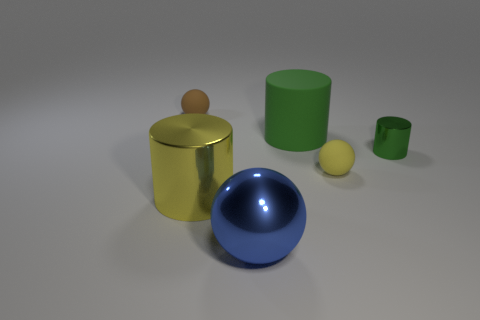Add 3 tiny brown spheres. How many objects exist? 9 Subtract all small rubber spheres. How many spheres are left? 1 Add 6 yellow metal cylinders. How many yellow metal cylinders are left? 7 Add 4 small blue matte objects. How many small blue matte objects exist? 4 Subtract all green cylinders. How many cylinders are left? 1 Subtract 0 yellow blocks. How many objects are left? 6 Subtract 2 balls. How many balls are left? 1 Subtract all red spheres. Subtract all gray cylinders. How many spheres are left? 3 Subtract all green cubes. How many cyan cylinders are left? 0 Subtract all green shiny objects. Subtract all big shiny things. How many objects are left? 3 